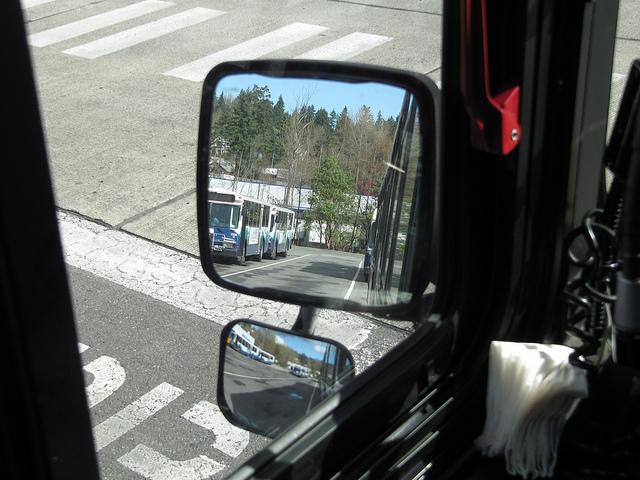Are the rear view mirror straight?
Write a very short answer. Yes. What is the person in the driver's seat doing?
Concise answer only. Driving. How is the bus driver feeling?
Write a very short answer. Happy. Are there any buses near?
Short answer required. Yes. Is there a human in the reflection?
Write a very short answer. No. Is there a dog in the image?
Answer briefly. No. Is there a forest behind the vehicle?
Write a very short answer. Yes. Is the mirror clean?
Answer briefly. Yes. 